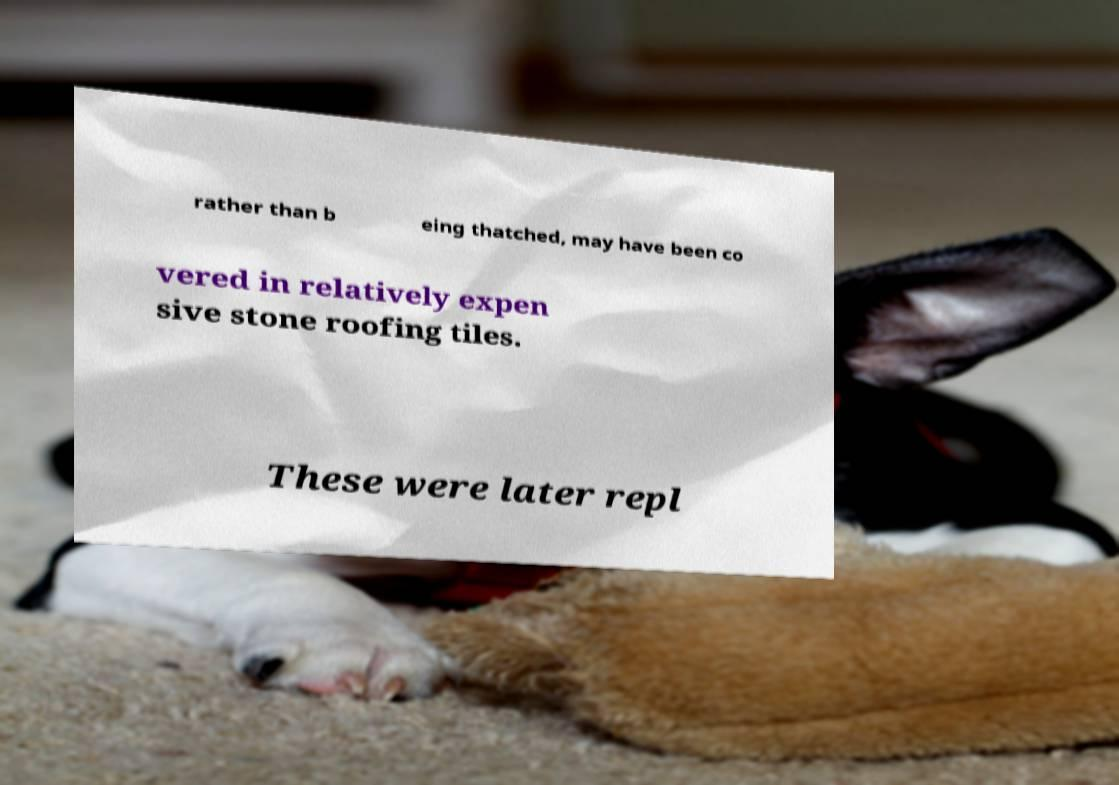Can you accurately transcribe the text from the provided image for me? rather than b eing thatched, may have been co vered in relatively expen sive stone roofing tiles. These were later repl 